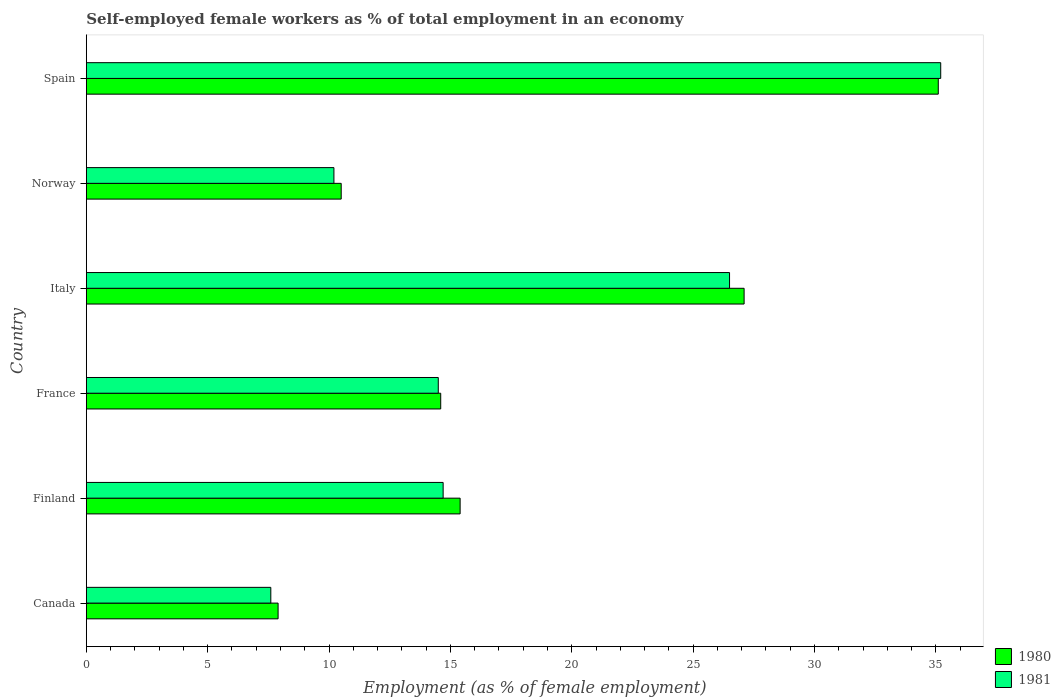Are the number of bars per tick equal to the number of legend labels?
Offer a terse response. Yes. How many bars are there on the 4th tick from the top?
Provide a short and direct response. 2. How many bars are there on the 4th tick from the bottom?
Offer a terse response. 2. What is the label of the 6th group of bars from the top?
Keep it short and to the point. Canada. What is the percentage of self-employed female workers in 1981 in Spain?
Give a very brief answer. 35.2. Across all countries, what is the maximum percentage of self-employed female workers in 1980?
Offer a very short reply. 35.1. Across all countries, what is the minimum percentage of self-employed female workers in 1980?
Your answer should be very brief. 7.9. In which country was the percentage of self-employed female workers in 1980 minimum?
Your answer should be compact. Canada. What is the total percentage of self-employed female workers in 1981 in the graph?
Make the answer very short. 108.7. What is the difference between the percentage of self-employed female workers in 1981 in Canada and that in Finland?
Offer a terse response. -7.1. What is the difference between the percentage of self-employed female workers in 1980 in Canada and the percentage of self-employed female workers in 1981 in France?
Offer a terse response. -6.6. What is the average percentage of self-employed female workers in 1981 per country?
Keep it short and to the point. 18.12. What is the difference between the percentage of self-employed female workers in 1980 and percentage of self-employed female workers in 1981 in France?
Provide a short and direct response. 0.1. In how many countries, is the percentage of self-employed female workers in 1981 greater than 13 %?
Ensure brevity in your answer.  4. What is the ratio of the percentage of self-employed female workers in 1981 in Canada to that in Spain?
Offer a very short reply. 0.22. Is the difference between the percentage of self-employed female workers in 1980 in Canada and Finland greater than the difference between the percentage of self-employed female workers in 1981 in Canada and Finland?
Your answer should be compact. No. What is the difference between the highest and the second highest percentage of self-employed female workers in 1981?
Your answer should be compact. 8.7. What is the difference between the highest and the lowest percentage of self-employed female workers in 1981?
Provide a succinct answer. 27.6. What does the 1st bar from the top in Finland represents?
Ensure brevity in your answer.  1981. What does the 1st bar from the bottom in Finland represents?
Give a very brief answer. 1980. How many bars are there?
Your response must be concise. 12. Are all the bars in the graph horizontal?
Provide a succinct answer. Yes. How many countries are there in the graph?
Your answer should be compact. 6. What is the title of the graph?
Offer a terse response. Self-employed female workers as % of total employment in an economy. Does "1978" appear as one of the legend labels in the graph?
Make the answer very short. No. What is the label or title of the X-axis?
Your answer should be compact. Employment (as % of female employment). What is the label or title of the Y-axis?
Your answer should be compact. Country. What is the Employment (as % of female employment) of 1980 in Canada?
Your answer should be very brief. 7.9. What is the Employment (as % of female employment) in 1981 in Canada?
Keep it short and to the point. 7.6. What is the Employment (as % of female employment) in 1980 in Finland?
Offer a terse response. 15.4. What is the Employment (as % of female employment) of 1981 in Finland?
Your answer should be very brief. 14.7. What is the Employment (as % of female employment) of 1980 in France?
Offer a very short reply. 14.6. What is the Employment (as % of female employment) of 1981 in France?
Your answer should be very brief. 14.5. What is the Employment (as % of female employment) in 1980 in Italy?
Your answer should be very brief. 27.1. What is the Employment (as % of female employment) in 1980 in Norway?
Your answer should be compact. 10.5. What is the Employment (as % of female employment) of 1981 in Norway?
Make the answer very short. 10.2. What is the Employment (as % of female employment) in 1980 in Spain?
Your response must be concise. 35.1. What is the Employment (as % of female employment) in 1981 in Spain?
Offer a terse response. 35.2. Across all countries, what is the maximum Employment (as % of female employment) in 1980?
Give a very brief answer. 35.1. Across all countries, what is the maximum Employment (as % of female employment) of 1981?
Make the answer very short. 35.2. Across all countries, what is the minimum Employment (as % of female employment) in 1980?
Your response must be concise. 7.9. Across all countries, what is the minimum Employment (as % of female employment) in 1981?
Your answer should be very brief. 7.6. What is the total Employment (as % of female employment) of 1980 in the graph?
Your response must be concise. 110.6. What is the total Employment (as % of female employment) of 1981 in the graph?
Offer a very short reply. 108.7. What is the difference between the Employment (as % of female employment) in 1980 in Canada and that in Finland?
Provide a succinct answer. -7.5. What is the difference between the Employment (as % of female employment) in 1980 in Canada and that in France?
Keep it short and to the point. -6.7. What is the difference between the Employment (as % of female employment) of 1980 in Canada and that in Italy?
Your response must be concise. -19.2. What is the difference between the Employment (as % of female employment) in 1981 in Canada and that in Italy?
Provide a short and direct response. -18.9. What is the difference between the Employment (as % of female employment) in 1980 in Canada and that in Norway?
Make the answer very short. -2.6. What is the difference between the Employment (as % of female employment) in 1980 in Canada and that in Spain?
Keep it short and to the point. -27.2. What is the difference between the Employment (as % of female employment) in 1981 in Canada and that in Spain?
Make the answer very short. -27.6. What is the difference between the Employment (as % of female employment) of 1980 in Finland and that in France?
Ensure brevity in your answer.  0.8. What is the difference between the Employment (as % of female employment) of 1981 in Finland and that in France?
Ensure brevity in your answer.  0.2. What is the difference between the Employment (as % of female employment) in 1980 in Finland and that in Norway?
Give a very brief answer. 4.9. What is the difference between the Employment (as % of female employment) in 1980 in Finland and that in Spain?
Provide a succinct answer. -19.7. What is the difference between the Employment (as % of female employment) of 1981 in Finland and that in Spain?
Give a very brief answer. -20.5. What is the difference between the Employment (as % of female employment) of 1980 in France and that in Italy?
Offer a terse response. -12.5. What is the difference between the Employment (as % of female employment) in 1980 in France and that in Spain?
Provide a short and direct response. -20.5. What is the difference between the Employment (as % of female employment) in 1981 in France and that in Spain?
Keep it short and to the point. -20.7. What is the difference between the Employment (as % of female employment) of 1980 in Italy and that in Norway?
Your answer should be very brief. 16.6. What is the difference between the Employment (as % of female employment) in 1981 in Italy and that in Norway?
Ensure brevity in your answer.  16.3. What is the difference between the Employment (as % of female employment) of 1980 in Italy and that in Spain?
Ensure brevity in your answer.  -8. What is the difference between the Employment (as % of female employment) in 1980 in Norway and that in Spain?
Provide a short and direct response. -24.6. What is the difference between the Employment (as % of female employment) in 1981 in Norway and that in Spain?
Ensure brevity in your answer.  -25. What is the difference between the Employment (as % of female employment) in 1980 in Canada and the Employment (as % of female employment) in 1981 in Italy?
Provide a short and direct response. -18.6. What is the difference between the Employment (as % of female employment) in 1980 in Canada and the Employment (as % of female employment) in 1981 in Spain?
Provide a succinct answer. -27.3. What is the difference between the Employment (as % of female employment) in 1980 in Finland and the Employment (as % of female employment) in 1981 in France?
Offer a terse response. 0.9. What is the difference between the Employment (as % of female employment) in 1980 in Finland and the Employment (as % of female employment) in 1981 in Italy?
Ensure brevity in your answer.  -11.1. What is the difference between the Employment (as % of female employment) in 1980 in Finland and the Employment (as % of female employment) in 1981 in Norway?
Ensure brevity in your answer.  5.2. What is the difference between the Employment (as % of female employment) of 1980 in Finland and the Employment (as % of female employment) of 1981 in Spain?
Keep it short and to the point. -19.8. What is the difference between the Employment (as % of female employment) of 1980 in France and the Employment (as % of female employment) of 1981 in Norway?
Give a very brief answer. 4.4. What is the difference between the Employment (as % of female employment) of 1980 in France and the Employment (as % of female employment) of 1981 in Spain?
Ensure brevity in your answer.  -20.6. What is the difference between the Employment (as % of female employment) in 1980 in Norway and the Employment (as % of female employment) in 1981 in Spain?
Provide a short and direct response. -24.7. What is the average Employment (as % of female employment) in 1980 per country?
Offer a terse response. 18.43. What is the average Employment (as % of female employment) in 1981 per country?
Provide a short and direct response. 18.12. What is the difference between the Employment (as % of female employment) in 1980 and Employment (as % of female employment) in 1981 in Canada?
Your answer should be compact. 0.3. What is the difference between the Employment (as % of female employment) in 1980 and Employment (as % of female employment) in 1981 in France?
Your answer should be compact. 0.1. What is the difference between the Employment (as % of female employment) in 1980 and Employment (as % of female employment) in 1981 in Norway?
Ensure brevity in your answer.  0.3. What is the difference between the Employment (as % of female employment) in 1980 and Employment (as % of female employment) in 1981 in Spain?
Ensure brevity in your answer.  -0.1. What is the ratio of the Employment (as % of female employment) in 1980 in Canada to that in Finland?
Your answer should be very brief. 0.51. What is the ratio of the Employment (as % of female employment) in 1981 in Canada to that in Finland?
Offer a terse response. 0.52. What is the ratio of the Employment (as % of female employment) in 1980 in Canada to that in France?
Make the answer very short. 0.54. What is the ratio of the Employment (as % of female employment) of 1981 in Canada to that in France?
Keep it short and to the point. 0.52. What is the ratio of the Employment (as % of female employment) of 1980 in Canada to that in Italy?
Provide a short and direct response. 0.29. What is the ratio of the Employment (as % of female employment) in 1981 in Canada to that in Italy?
Provide a short and direct response. 0.29. What is the ratio of the Employment (as % of female employment) in 1980 in Canada to that in Norway?
Ensure brevity in your answer.  0.75. What is the ratio of the Employment (as % of female employment) in 1981 in Canada to that in Norway?
Provide a succinct answer. 0.75. What is the ratio of the Employment (as % of female employment) in 1980 in Canada to that in Spain?
Ensure brevity in your answer.  0.23. What is the ratio of the Employment (as % of female employment) of 1981 in Canada to that in Spain?
Make the answer very short. 0.22. What is the ratio of the Employment (as % of female employment) in 1980 in Finland to that in France?
Your response must be concise. 1.05. What is the ratio of the Employment (as % of female employment) of 1981 in Finland to that in France?
Your answer should be very brief. 1.01. What is the ratio of the Employment (as % of female employment) of 1980 in Finland to that in Italy?
Give a very brief answer. 0.57. What is the ratio of the Employment (as % of female employment) in 1981 in Finland to that in Italy?
Offer a very short reply. 0.55. What is the ratio of the Employment (as % of female employment) in 1980 in Finland to that in Norway?
Provide a short and direct response. 1.47. What is the ratio of the Employment (as % of female employment) of 1981 in Finland to that in Norway?
Ensure brevity in your answer.  1.44. What is the ratio of the Employment (as % of female employment) of 1980 in Finland to that in Spain?
Ensure brevity in your answer.  0.44. What is the ratio of the Employment (as % of female employment) in 1981 in Finland to that in Spain?
Provide a succinct answer. 0.42. What is the ratio of the Employment (as % of female employment) in 1980 in France to that in Italy?
Your response must be concise. 0.54. What is the ratio of the Employment (as % of female employment) in 1981 in France to that in Italy?
Your response must be concise. 0.55. What is the ratio of the Employment (as % of female employment) in 1980 in France to that in Norway?
Offer a terse response. 1.39. What is the ratio of the Employment (as % of female employment) in 1981 in France to that in Norway?
Make the answer very short. 1.42. What is the ratio of the Employment (as % of female employment) of 1980 in France to that in Spain?
Your response must be concise. 0.42. What is the ratio of the Employment (as % of female employment) of 1981 in France to that in Spain?
Offer a terse response. 0.41. What is the ratio of the Employment (as % of female employment) in 1980 in Italy to that in Norway?
Keep it short and to the point. 2.58. What is the ratio of the Employment (as % of female employment) of 1981 in Italy to that in Norway?
Provide a succinct answer. 2.6. What is the ratio of the Employment (as % of female employment) in 1980 in Italy to that in Spain?
Your response must be concise. 0.77. What is the ratio of the Employment (as % of female employment) of 1981 in Italy to that in Spain?
Your response must be concise. 0.75. What is the ratio of the Employment (as % of female employment) of 1980 in Norway to that in Spain?
Your answer should be very brief. 0.3. What is the ratio of the Employment (as % of female employment) in 1981 in Norway to that in Spain?
Keep it short and to the point. 0.29. What is the difference between the highest and the second highest Employment (as % of female employment) in 1981?
Your answer should be very brief. 8.7. What is the difference between the highest and the lowest Employment (as % of female employment) in 1980?
Your answer should be compact. 27.2. What is the difference between the highest and the lowest Employment (as % of female employment) of 1981?
Ensure brevity in your answer.  27.6. 